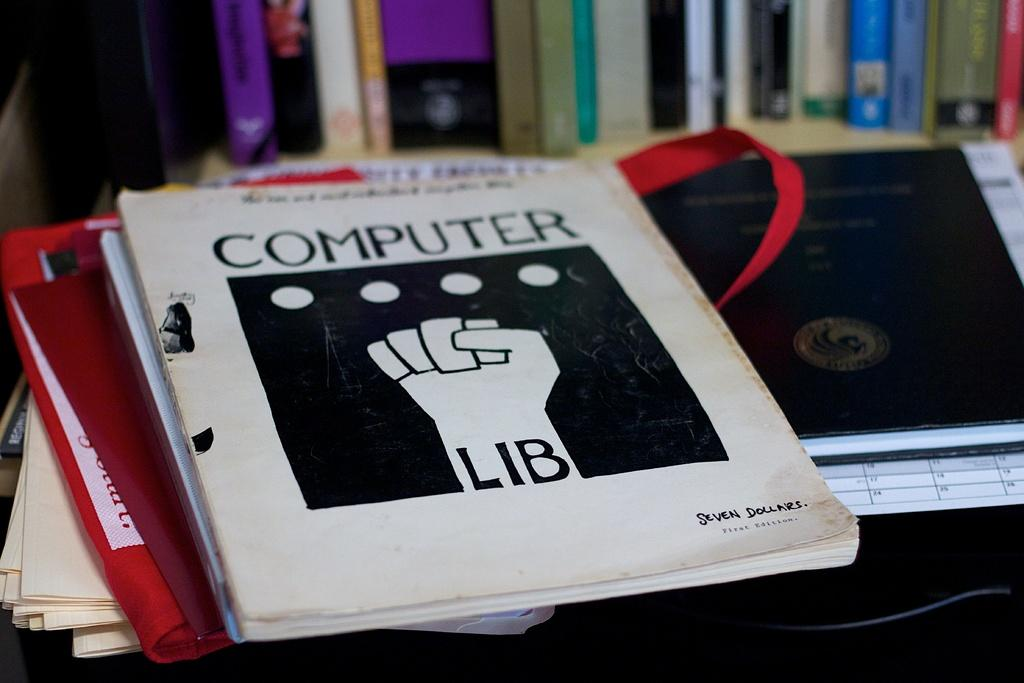<image>
Write a terse but informative summary of the picture. A black and white computer lib book sits on a stack of folders. 